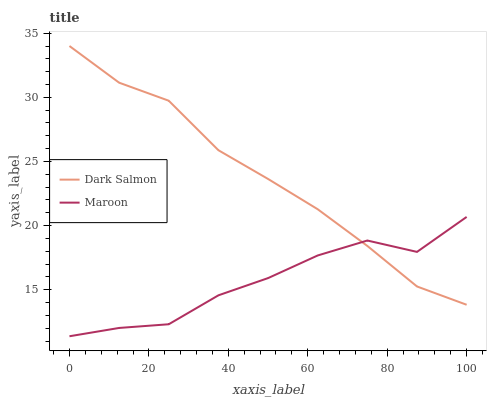Does Maroon have the minimum area under the curve?
Answer yes or no. Yes. Does Dark Salmon have the maximum area under the curve?
Answer yes or no. Yes. Does Maroon have the maximum area under the curve?
Answer yes or no. No. Is Dark Salmon the smoothest?
Answer yes or no. Yes. Is Maroon the roughest?
Answer yes or no. Yes. Is Maroon the smoothest?
Answer yes or no. No. Does Maroon have the lowest value?
Answer yes or no. Yes. Does Dark Salmon have the highest value?
Answer yes or no. Yes. Does Maroon have the highest value?
Answer yes or no. No. Does Maroon intersect Dark Salmon?
Answer yes or no. Yes. Is Maroon less than Dark Salmon?
Answer yes or no. No. Is Maroon greater than Dark Salmon?
Answer yes or no. No. 